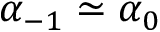Convert formula to latex. <formula><loc_0><loc_0><loc_500><loc_500>\alpha _ { - 1 } \simeq \alpha _ { 0 }</formula> 